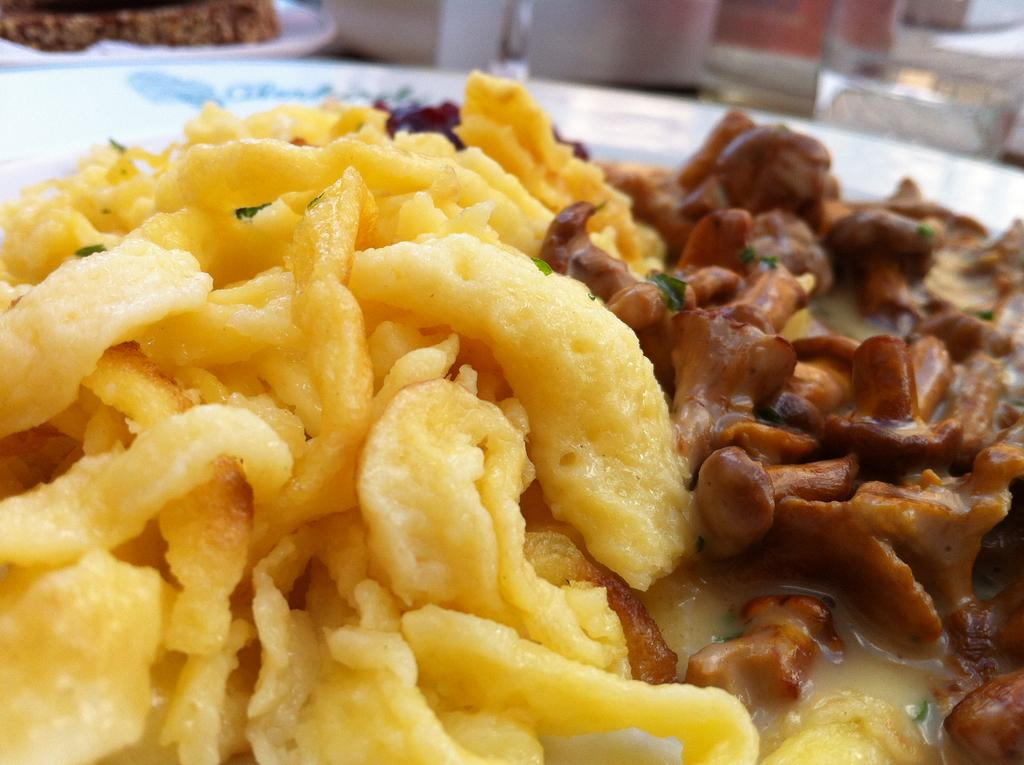What can be seen on the plates in the image? There are plates with food items in the image. What is in the glass that is visible in the image? There is a glass with water in the image. Can you describe any other objects present in the image? There are additional objects present in the image, but their specific details are not mentioned in the provided facts. What month is it in the image? The provided facts do not mention any information about the month, so it cannot be determined from the image. 